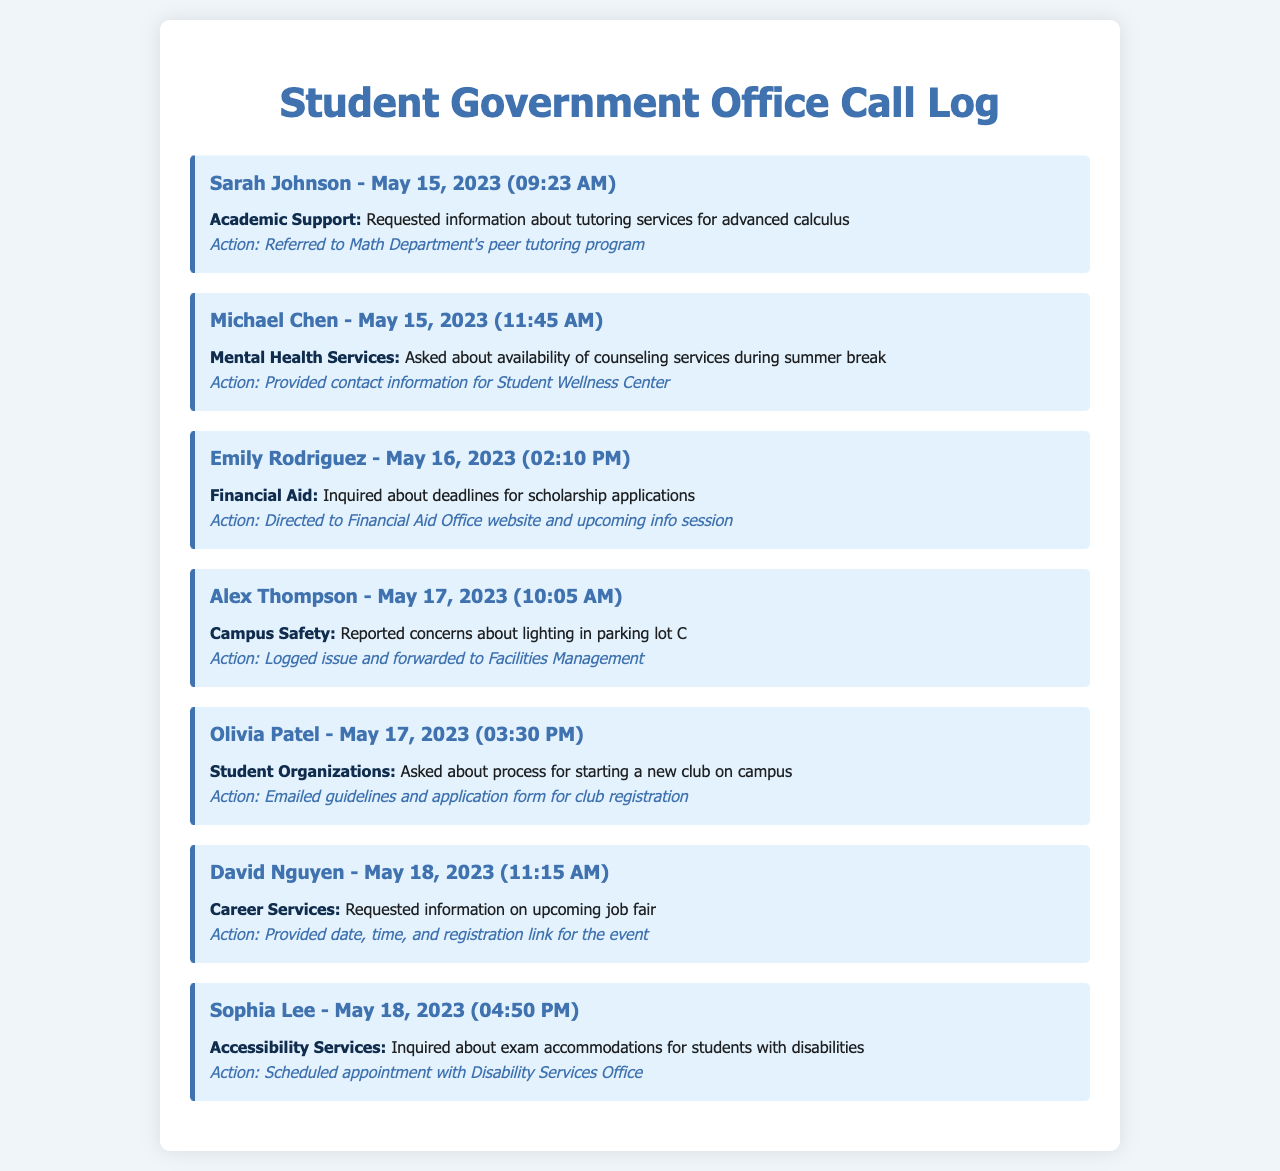What is the name of the first caller? The first caller is listed at the top of the document with their name and date of call, which is Sarah Johnson.
Answer: Sarah Johnson What type of inquiry did Michael Chen make? Michael Chen's inquiry type is categorized as Mental Health Services, as indicated in the log entry.
Answer: Mental Health Services When did Olivia Patel call? The date and time of Olivia Patel's call are specified in her log entry, which is May 17, 2023 at 03:30 PM.
Answer: May 17, 2023 (03:30 PM) What action was taken for Emily Rodriguez's inquiry? The action taken for Emily Rodriguez was to direct her to the Financial Aid Office website and info session, as noted in her log.
Answer: Directed to Financial Aid Office website and upcoming info session How many inquiries fall under the category of Academic Support? The log shows one inquiry categorized as Academic Support, specifically from Sarah Johnson, indicating the total count.
Answer: 1 Who requested information regarding exam accommodations? Sophia Lee requested information about exam accommodations for students with disabilities, as documented in her call entry.
Answer: Sophia Lee What concern did Alex Thompson report? Alex Thompson reported concerns about the lighting in parking lot C, which is detailed in his inquiry.
Answer: Lighting in parking lot C What was provided to David Nguyen related to the job fair? David Nguyen was provided with the date, time, and registration link for the upcoming job fair, as stated in his log entry.
Answer: Date, time, and registration link for the event 